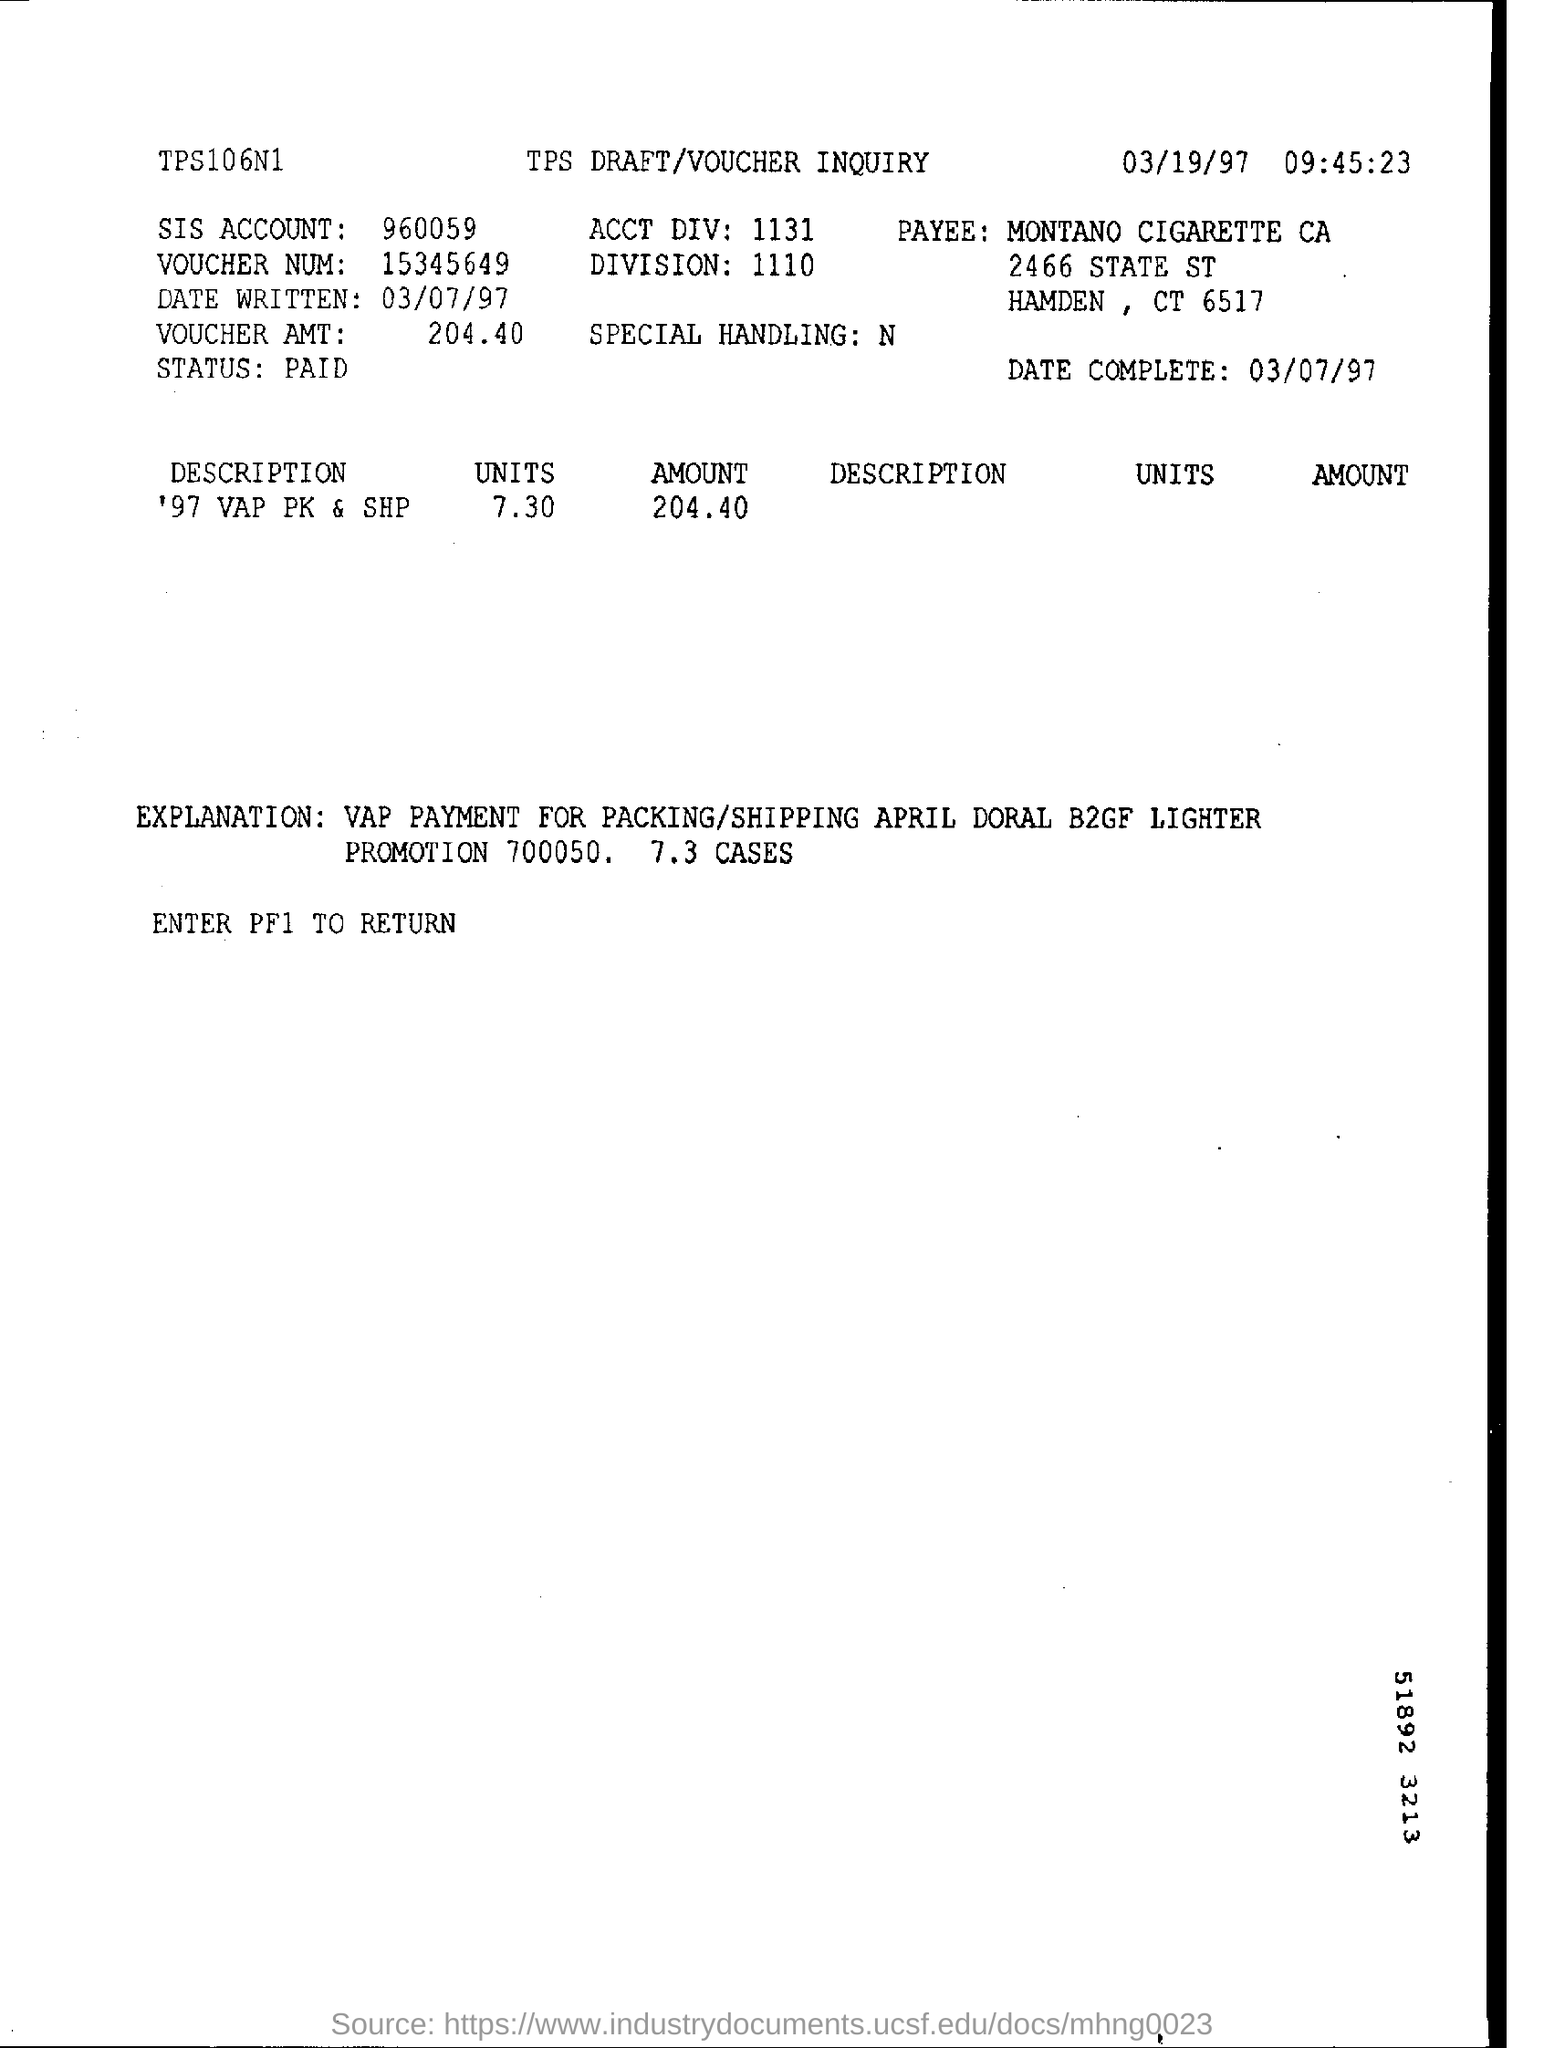What is the  "date complete" ?
Ensure brevity in your answer.  03/07/97. What is the time mentioned ?
Provide a short and direct response. 09:45:23. What is mentioned in the date written ?
Give a very brief answer. 03/07/97. What is sis account number ?
Provide a succinct answer. 960059. What is the voucher amt ?
Provide a succinct answer. 204.40. What is mentioned in the date complete
Your answer should be compact. 03/07/97. Who is the payee ?
Keep it short and to the point. MONTANO CIGARETTE CA. What is the status of the payment ?
Offer a very short reply. PAID. What is the division number ?
Your response must be concise. 1110. 